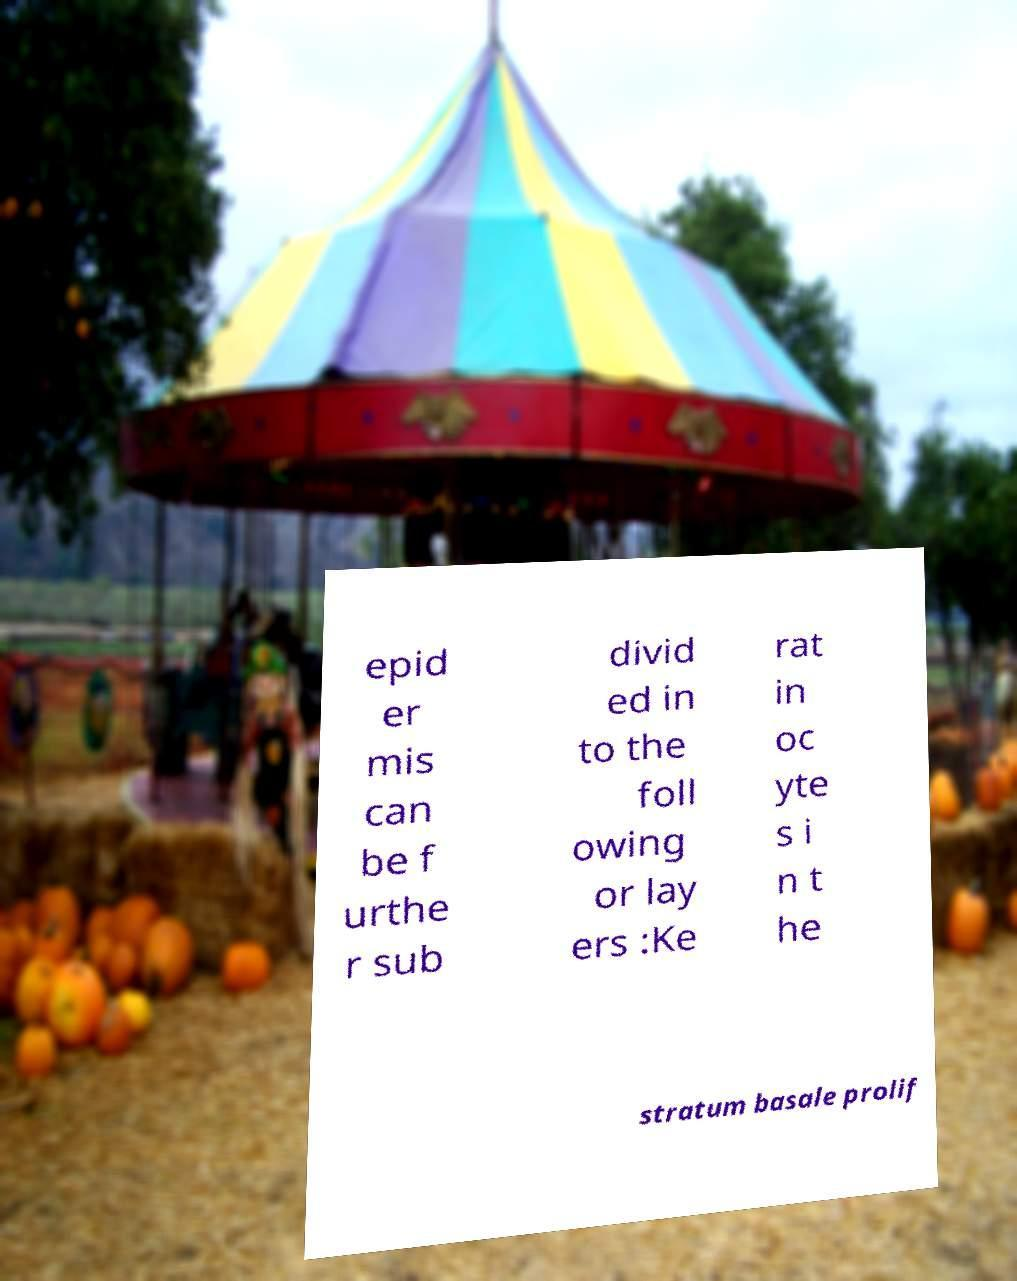For documentation purposes, I need the text within this image transcribed. Could you provide that? epid er mis can be f urthe r sub divid ed in to the foll owing or lay ers :Ke rat in oc yte s i n t he stratum basale prolif 